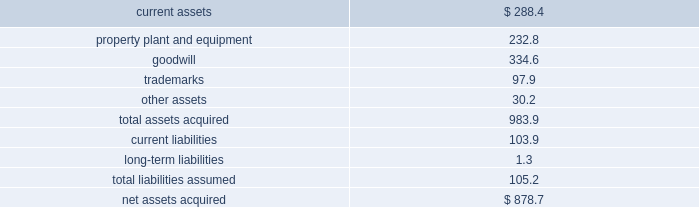492010 annual report consolidation 2013 effective february 28 , 2010 , the company adopted the fasb amended guidance for con- solidation .
This guidance clarifies that the scope of the decrease in ownership provisions applies to the follow- ing : ( i ) a subsidiary or group of assets that is a business or nonprofit activity ; ( ii ) a subsidiary that is a business or nonprofit activity that is transferred to an equity method investee or joint venture ; and ( iii ) an exchange of a group of assets that constitutes a business or nonprofit activ- ity for a noncontrolling interest in an entity ( including an equity method investee or joint venture ) .
This guidance also expands the disclosures about the deconsolidation of a subsidiary or derecognition of a group of assets within the scope of the guidance .
The adoption of this guidance did not have a material impact on the company 2019s consolidated financial statements .
3 . acquisitions : acquisition of bwe 2013 on december 17 , 2007 , the company acquired all of the issued and outstanding capital stock of beam wine estates , inc .
( 201cbwe 201d ) , an indirect wholly-owned subsidiary of fortune brands , inc. , together with bwe 2019s subsidiaries : atlas peak vineyards , inc. , buena vista winery , inc. , clos du bois , inc. , gary farrell wines , inc .
And peak wines international , inc .
( the 201cbwe acquisition 201d ) .
As a result of the bwe acquisition , the company acquired the u.s .
Wine portfolio of fortune brands , inc. , including certain wineries , vineyards or inter- ests therein in the state of california , as well as various super-premium and fine california wine brands including clos du bois and wild horse .
The bwe acquisition sup- ports the company 2019s strategy of strengthening its portfolio with fast-growing super-premium and above wines .
The bwe acquisition strengthens the company 2019s position as the leading wine company in the world and the leading premium wine company in the u.s .
Total consideration paid in cash was $ 877.3 million .
In addition , the company incurred direct acquisition costs of $ 1.4 million .
The purchase price was financed with the net proceeds from the company 2019s december 2007 senior notes ( as defined in note 11 ) and revolver borrowings under the company 2019s june 2006 credit agreement , as amended in february 2007 and november 2007 ( as defined in note 11 ) .
In accordance with the purchase method of accounting , the acquired net assets are recorded at fair value at the date of acquisition .
The purchase price was based primarily on the estimated future operating results of the bwe business , including the factors described above .
In june 2008 , the company sold certain businesses consisting of several of the california wineries and wine brands acquired in the bwe acquisition , as well as certain wineries and wine brands from the states of washington and idaho ( collectively , the 201cpacific northwest business 201d ) ( see note 7 ) .
The results of operations of the bwe business are reported in the constellation wines segment and are included in the consolidated results of operations of the company from the date of acquisition .
The table summarizes the fair values of the assets acquired and liabilities assumed in the bwe acquisition at the date of acquisition .
( in millions ) current assets $ 288.4 property , plant and equipment 232.8 .
Other assets 30.2 total assets acquired 983.9 current liabilities 103.9 long-term liabilities 1.3 total liabilities assumed 105.2 net assets acquired $ 878.7 the trademarks are not subject to amortization .
All of the goodwill is expected to be deductible for tax purposes .
Acquisition of svedka 2013 on march 19 , 2007 , the company acquired the svedka vodka brand ( 201csvedka 201d ) in connection with the acquisition of spirits marque one llc and related business ( the 201csvedka acquisition 201d ) .
Svedka is a premium swedish vodka .
At the time of the acquisition , the svedka acquisition supported the company 2019s strategy of expanding the company 2019s premium spirits business and provided a foundation from which the company looked to leverage its existing and future premium spirits portfolio for growth .
In addition , svedka complemented the company 2019s then existing portfolio of super-premium and value vodka brands by adding a premium vodka brand .
Total consideration paid in cash for the svedka acquisition was $ 385.8 million .
In addition , the company incurred direct acquisition costs of $ 1.3 million .
The pur- chase price was financed with revolver borrowings under the company 2019s june 2006 credit agreement , as amended in february 2007 .
In accordance with the purchase method of accounting , the acquired net assets are recorded at fair value at the date of acquisition .
The purchase price was based primarily on the estimated future operating results of the svedka business , including the factors described above .
The results of operations of the svedka business are reported in the constellation wines segment and are included in the consolidated results of operations of the company from the date of acquisition. .
What was the total of intangibles acquired in the bwe acquisition , in millions? 
Computations: (334.6 + 97.9)
Answer: 432.5. 